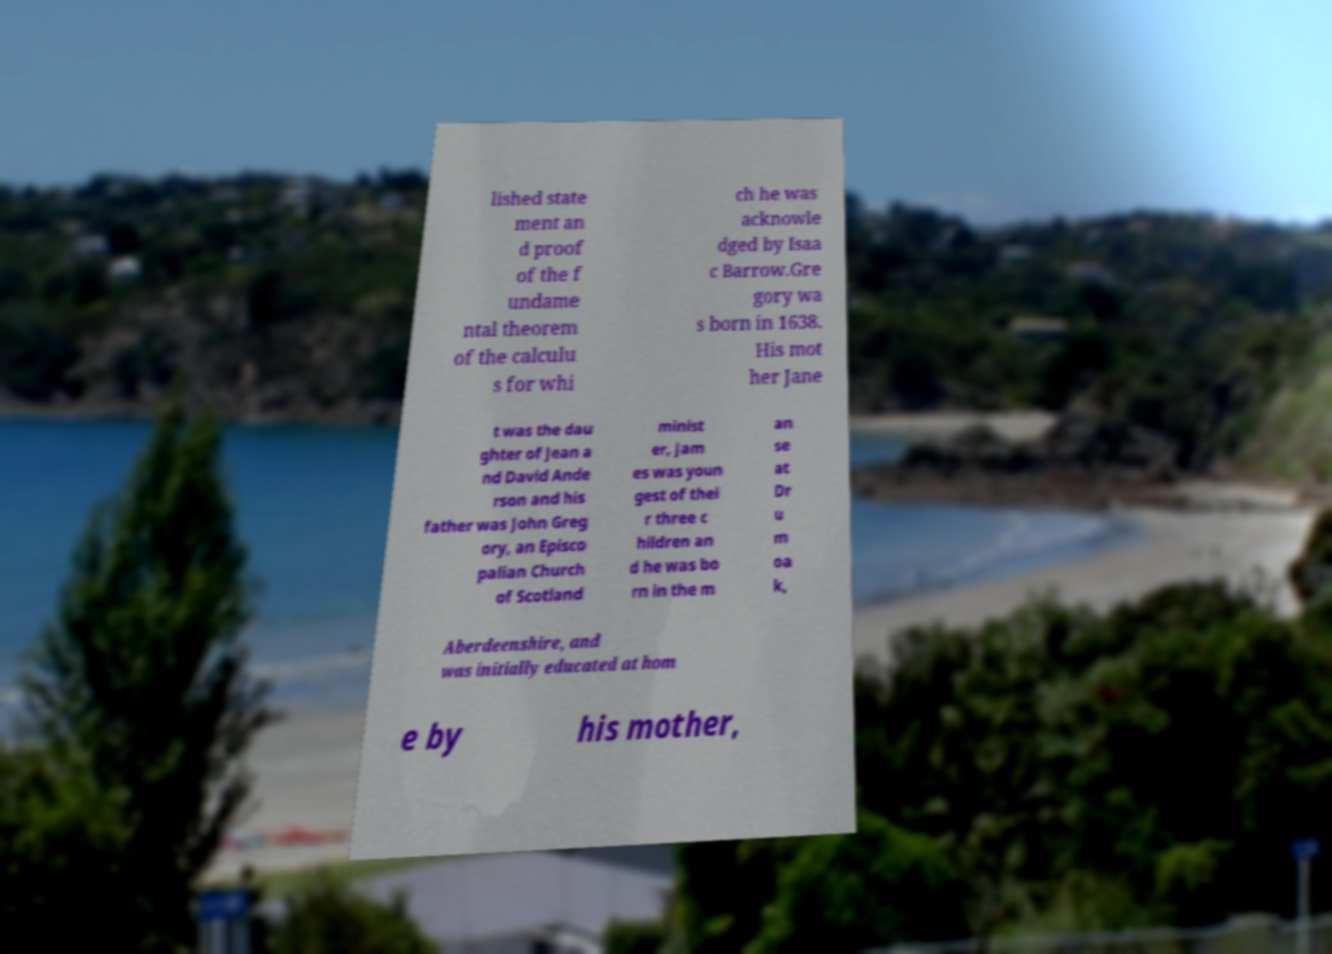Please read and relay the text visible in this image. What does it say? lished state ment an d proof of the f undame ntal theorem of the calculu s for whi ch he was acknowle dged by Isaa c Barrow.Gre gory wa s born in 1638. His mot her Jane t was the dau ghter of Jean a nd David Ande rson and his father was John Greg ory, an Episco palian Church of Scotland minist er, Jam es was youn gest of thei r three c hildren an d he was bo rn in the m an se at Dr u m oa k, Aberdeenshire, and was initially educated at hom e by his mother, 